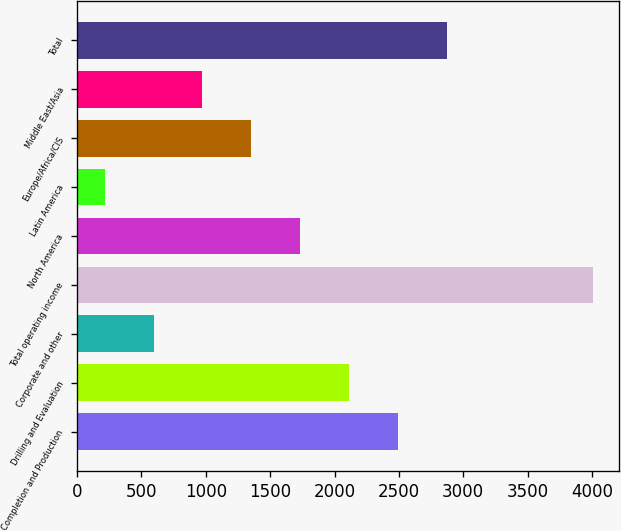Convert chart. <chart><loc_0><loc_0><loc_500><loc_500><bar_chart><fcel>Completion and Production<fcel>Drilling and Evaluation<fcel>Corporate and other<fcel>Total operating income<fcel>North America<fcel>Latin America<fcel>Europe/Africa/CIS<fcel>Middle East/Asia<fcel>Total<nl><fcel>2491.6<fcel>2112<fcel>593.6<fcel>4010<fcel>1732.4<fcel>214<fcel>1352.8<fcel>973.2<fcel>2871.2<nl></chart> 